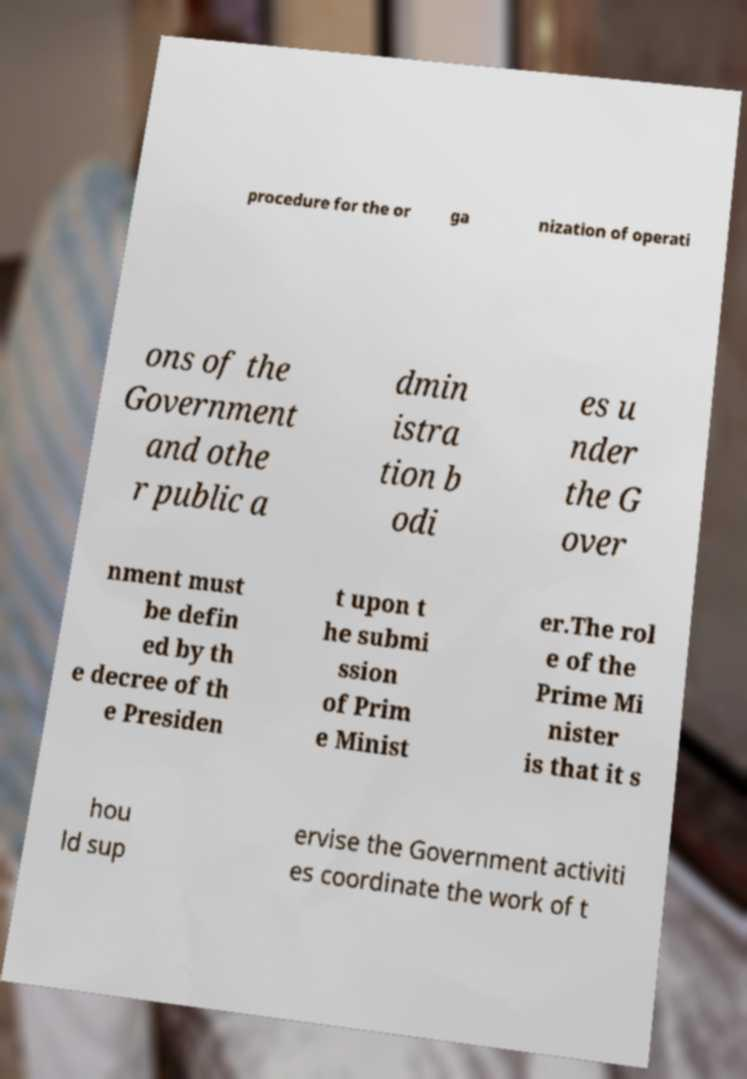Please identify and transcribe the text found in this image. procedure for the or ga nization of operati ons of the Government and othe r public a dmin istra tion b odi es u nder the G over nment must be defin ed by th e decree of th e Presiden t upon t he submi ssion of Prim e Minist er.The rol e of the Prime Mi nister is that it s hou ld sup ervise the Government activiti es coordinate the work of t 